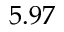Convert formula to latex. <formula><loc_0><loc_0><loc_500><loc_500>5 . 9 7</formula> 